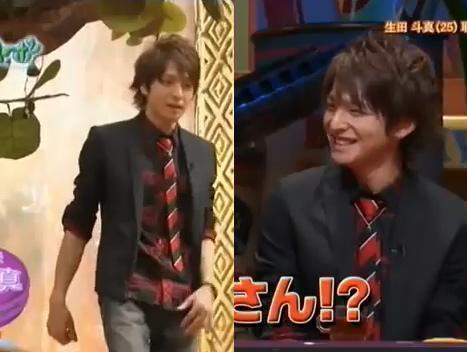Where would the contents of this image probably be seen exactly assis?
Choose the correct response, then elucidate: 'Answer: answer
Rationale: rationale.'
Options: On floor, in person, on painting, on tv. Answer: on tv.
Rationale: Since there is writing in front of the guy, the person seeing this would be on television. 